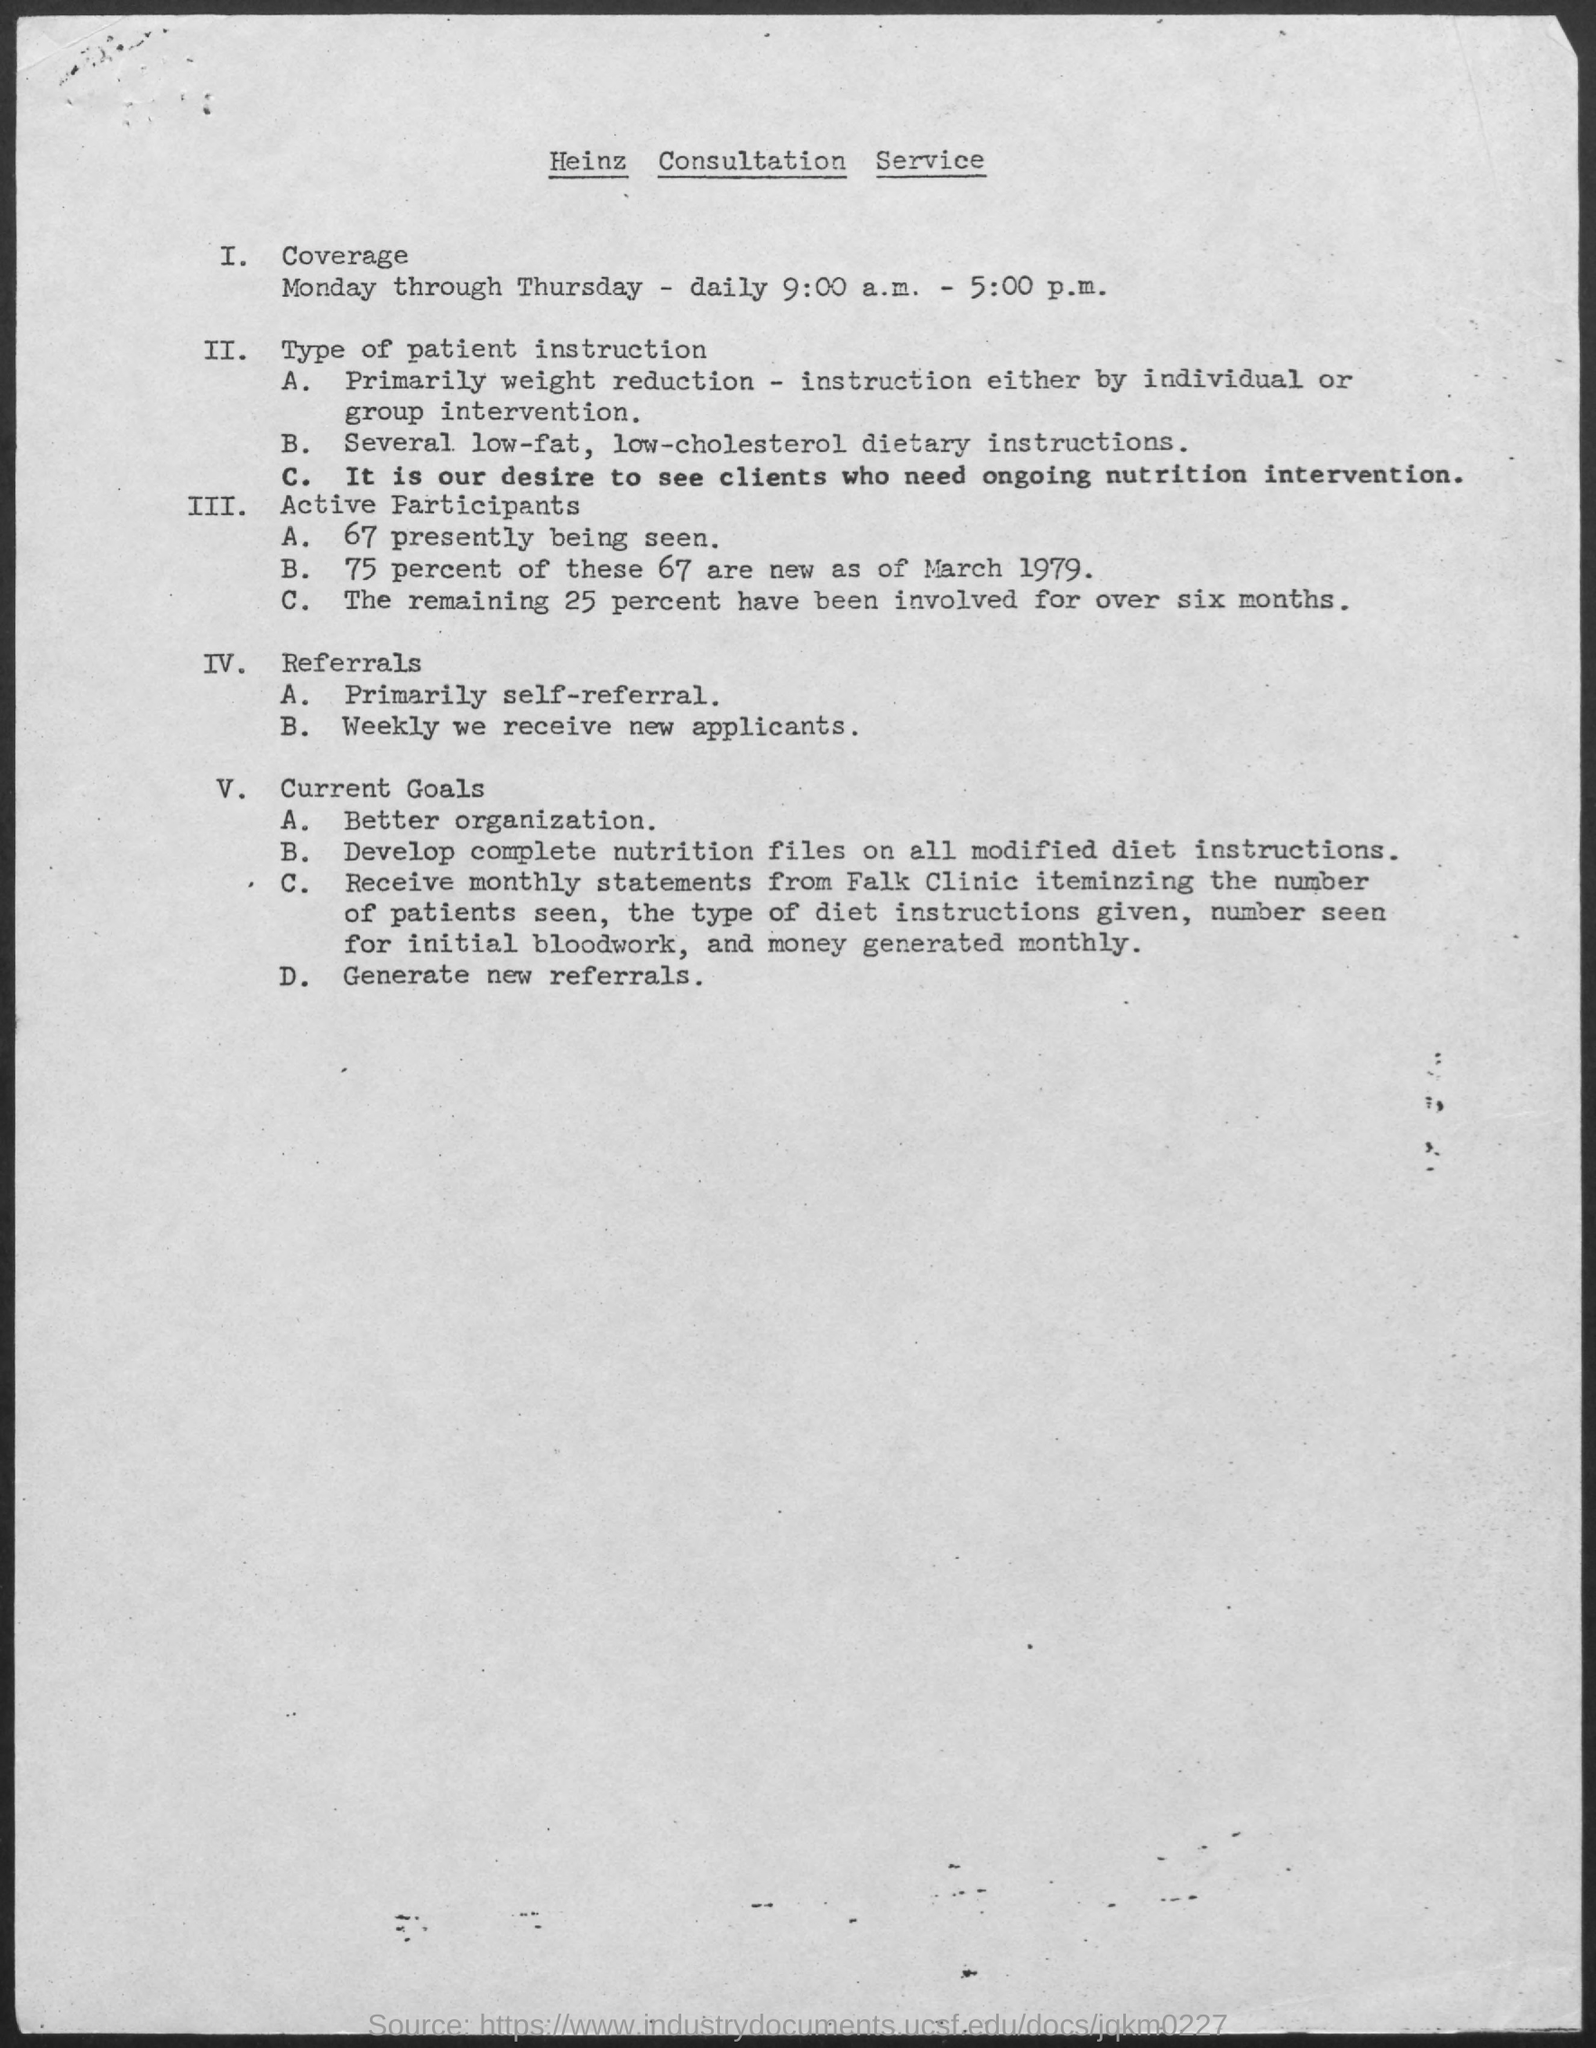Which consultation Service name is mentioned in the document?
Give a very brief answer. Heinz consultation service. 